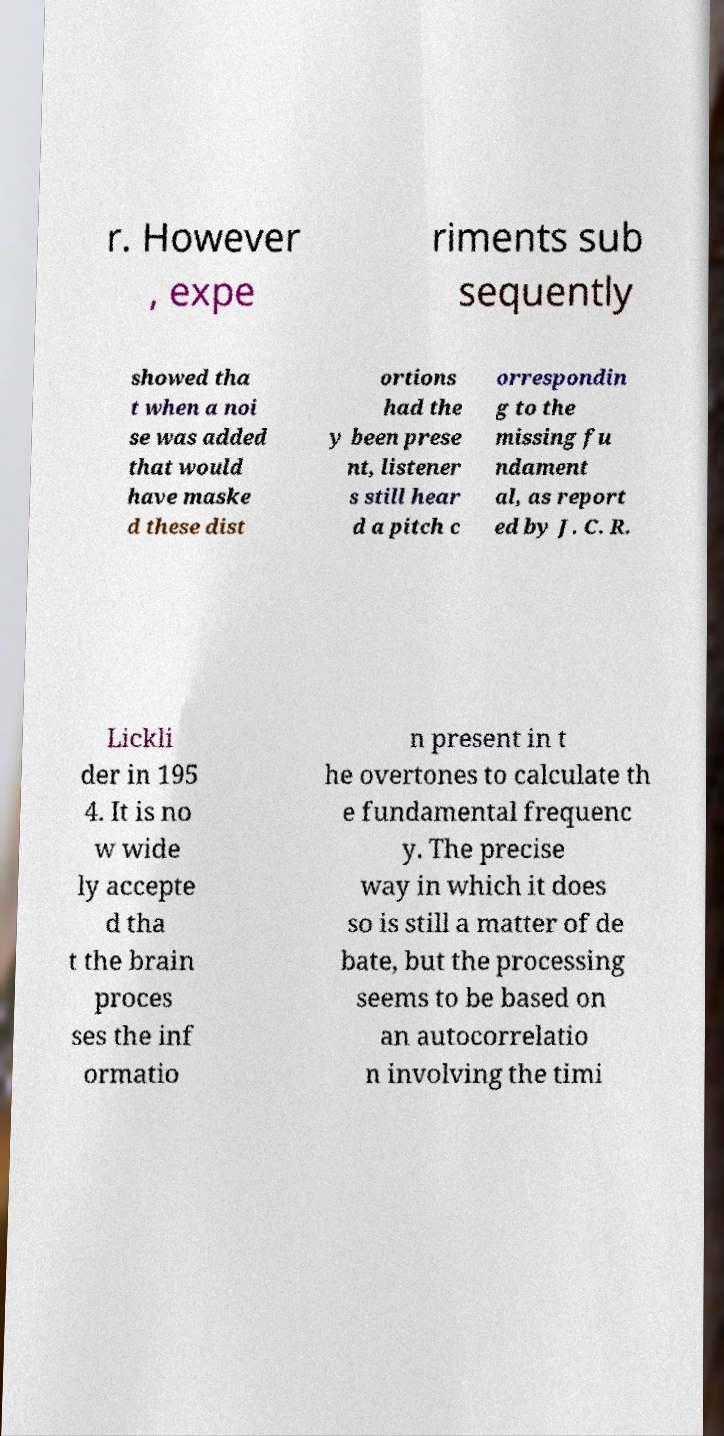What messages or text are displayed in this image? I need them in a readable, typed format. r. However , expe riments sub sequently showed tha t when a noi se was added that would have maske d these dist ortions had the y been prese nt, listener s still hear d a pitch c orrespondin g to the missing fu ndament al, as report ed by J. C. R. Lickli der in 195 4. It is no w wide ly accepte d tha t the brain proces ses the inf ormatio n present in t he overtones to calculate th e fundamental frequenc y. The precise way in which it does so is still a matter of de bate, but the processing seems to be based on an autocorrelatio n involving the timi 